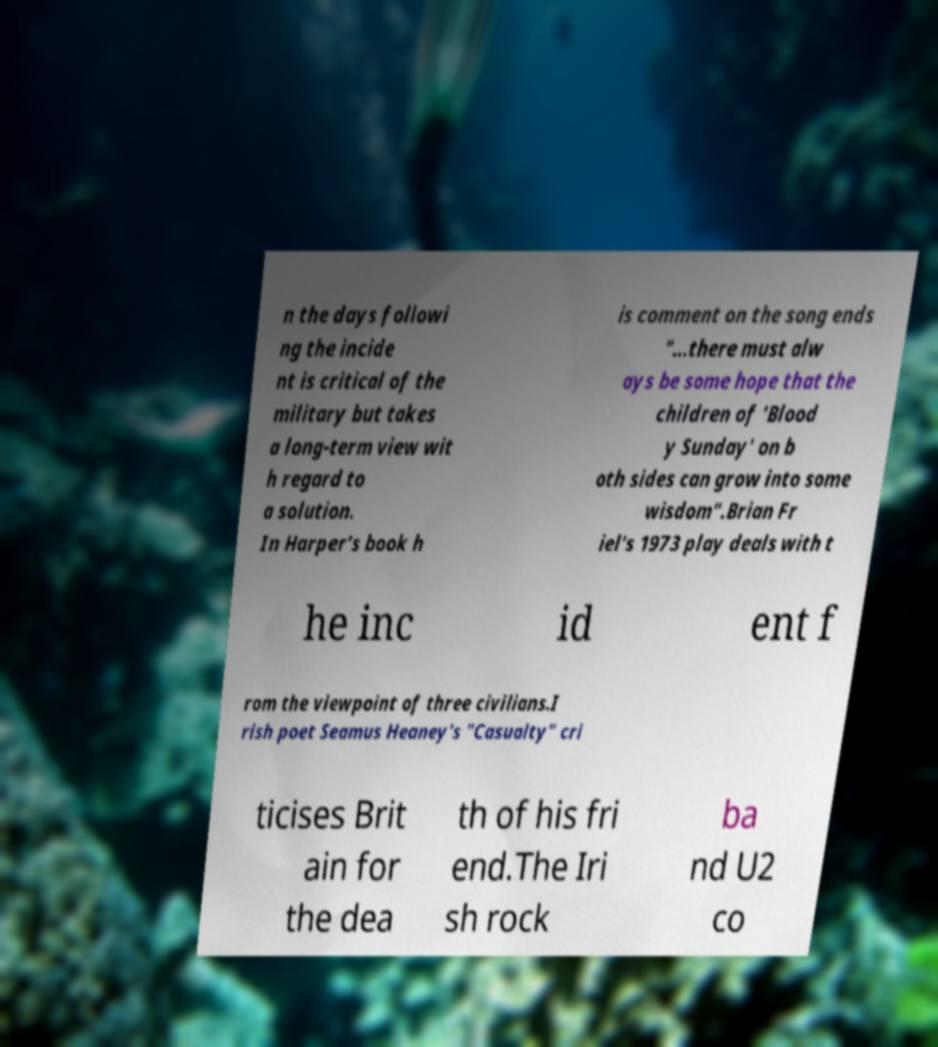Could you extract and type out the text from this image? n the days followi ng the incide nt is critical of the military but takes a long-term view wit h regard to a solution. In Harper's book h is comment on the song ends "…there must alw ays be some hope that the children of 'Blood y Sunday' on b oth sides can grow into some wisdom".Brian Fr iel's 1973 play deals with t he inc id ent f rom the viewpoint of three civilians.I rish poet Seamus Heaney's "Casualty" cri ticises Brit ain for the dea th of his fri end.The Iri sh rock ba nd U2 co 